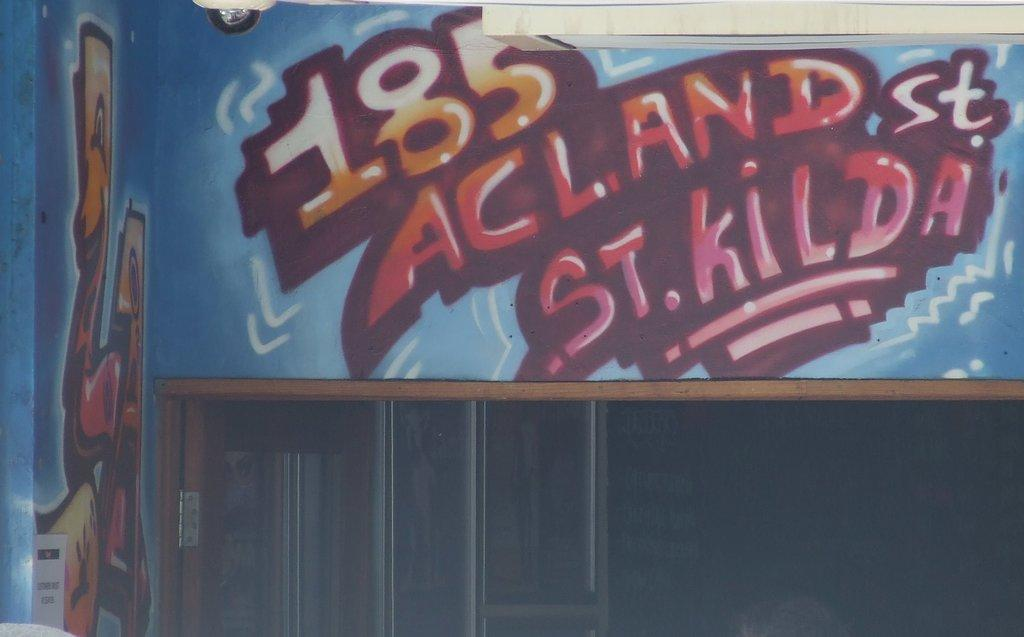<image>
Describe the image concisely. The grafitti talks about St Kilda specifically Acland Street. 